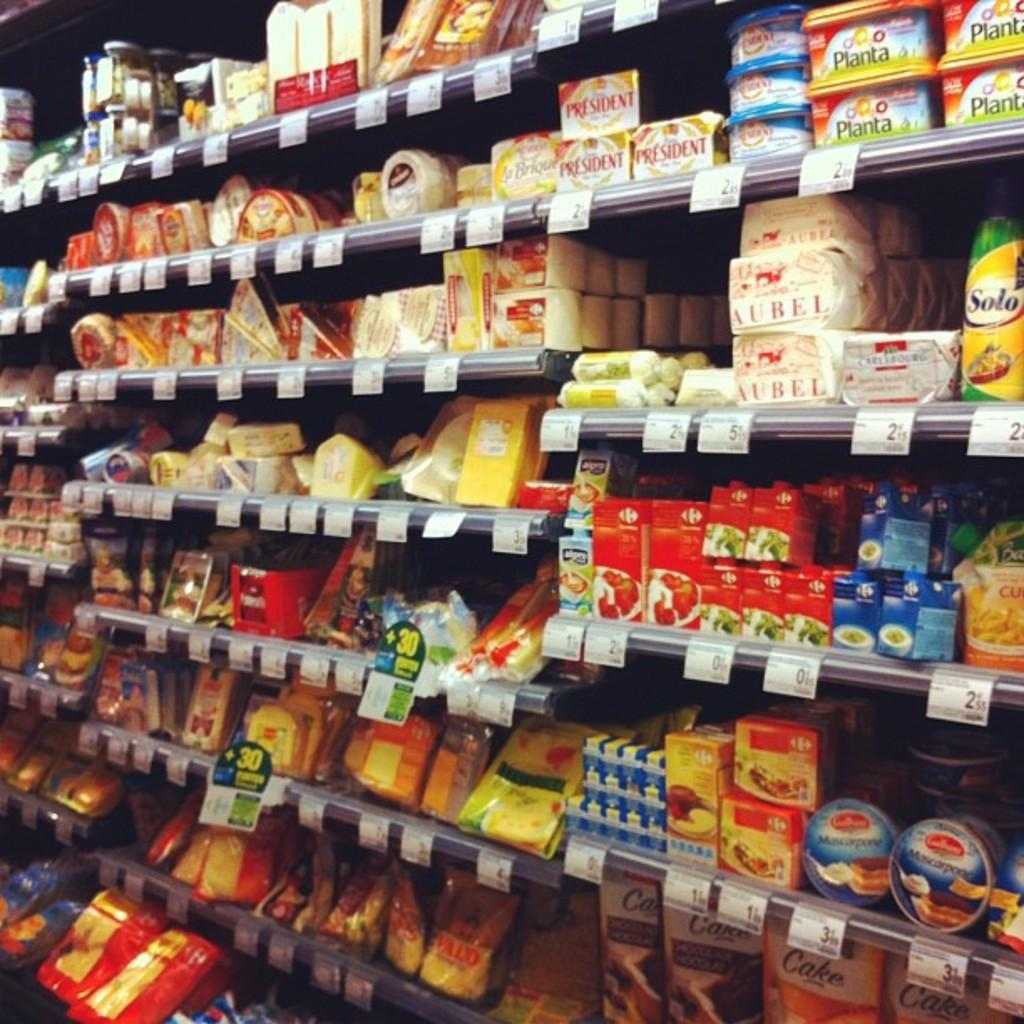<image>
Present a compact description of the photo's key features. A display of products in a market with one of the labels having the word AUBEL. 